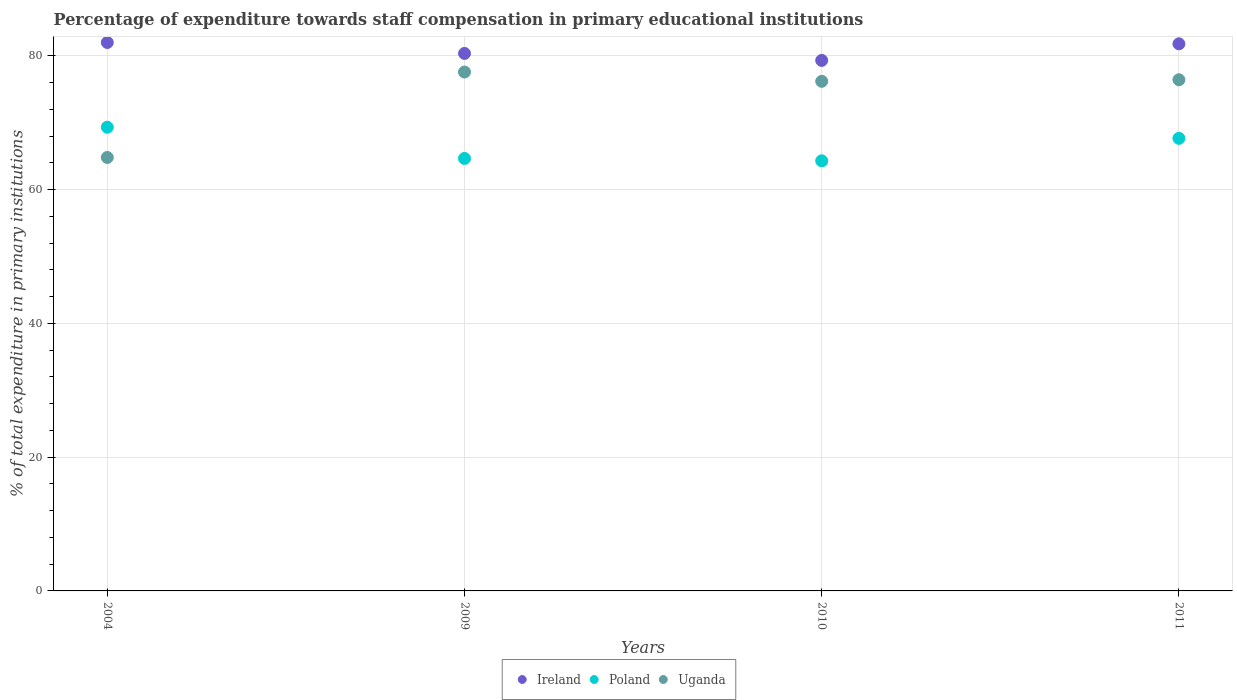How many different coloured dotlines are there?
Your answer should be very brief. 3. What is the percentage of expenditure towards staff compensation in Poland in 2004?
Give a very brief answer. 69.34. Across all years, what is the maximum percentage of expenditure towards staff compensation in Uganda?
Give a very brief answer. 77.58. Across all years, what is the minimum percentage of expenditure towards staff compensation in Ireland?
Keep it short and to the point. 79.32. What is the total percentage of expenditure towards staff compensation in Uganda in the graph?
Offer a terse response. 295.02. What is the difference between the percentage of expenditure towards staff compensation in Poland in 2009 and that in 2011?
Offer a terse response. -3. What is the difference between the percentage of expenditure towards staff compensation in Ireland in 2011 and the percentage of expenditure towards staff compensation in Uganda in 2010?
Your response must be concise. 5.6. What is the average percentage of expenditure towards staff compensation in Uganda per year?
Your answer should be compact. 73.76. In the year 2010, what is the difference between the percentage of expenditure towards staff compensation in Ireland and percentage of expenditure towards staff compensation in Poland?
Ensure brevity in your answer.  15.01. What is the ratio of the percentage of expenditure towards staff compensation in Uganda in 2010 to that in 2011?
Your answer should be compact. 1. What is the difference between the highest and the second highest percentage of expenditure towards staff compensation in Poland?
Offer a very short reply. 1.67. What is the difference between the highest and the lowest percentage of expenditure towards staff compensation in Ireland?
Offer a very short reply. 2.68. Is the sum of the percentage of expenditure towards staff compensation in Uganda in 2009 and 2010 greater than the maximum percentage of expenditure towards staff compensation in Poland across all years?
Offer a very short reply. Yes. Is it the case that in every year, the sum of the percentage of expenditure towards staff compensation in Ireland and percentage of expenditure towards staff compensation in Uganda  is greater than the percentage of expenditure towards staff compensation in Poland?
Give a very brief answer. Yes. Does the percentage of expenditure towards staff compensation in Ireland monotonically increase over the years?
Your answer should be compact. No. Is the percentage of expenditure towards staff compensation in Ireland strictly greater than the percentage of expenditure towards staff compensation in Uganda over the years?
Offer a terse response. Yes. How many dotlines are there?
Keep it short and to the point. 3. How many years are there in the graph?
Offer a very short reply. 4. What is the difference between two consecutive major ticks on the Y-axis?
Ensure brevity in your answer.  20. What is the title of the graph?
Provide a succinct answer. Percentage of expenditure towards staff compensation in primary educational institutions. Does "Slovak Republic" appear as one of the legend labels in the graph?
Keep it short and to the point. No. What is the label or title of the X-axis?
Give a very brief answer. Years. What is the label or title of the Y-axis?
Offer a very short reply. % of total expenditure in primary institutions. What is the % of total expenditure in primary institutions of Ireland in 2004?
Ensure brevity in your answer.  82. What is the % of total expenditure in primary institutions of Poland in 2004?
Ensure brevity in your answer.  69.34. What is the % of total expenditure in primary institutions in Uganda in 2004?
Offer a terse response. 64.81. What is the % of total expenditure in primary institutions of Ireland in 2009?
Your answer should be very brief. 80.37. What is the % of total expenditure in primary institutions in Poland in 2009?
Provide a short and direct response. 64.67. What is the % of total expenditure in primary institutions of Uganda in 2009?
Offer a terse response. 77.58. What is the % of total expenditure in primary institutions in Ireland in 2010?
Your response must be concise. 79.32. What is the % of total expenditure in primary institutions of Poland in 2010?
Provide a succinct answer. 64.31. What is the % of total expenditure in primary institutions of Uganda in 2010?
Provide a succinct answer. 76.2. What is the % of total expenditure in primary institutions in Ireland in 2011?
Provide a short and direct response. 81.8. What is the % of total expenditure in primary institutions in Poland in 2011?
Provide a short and direct response. 67.67. What is the % of total expenditure in primary institutions in Uganda in 2011?
Your answer should be compact. 76.43. Across all years, what is the maximum % of total expenditure in primary institutions of Ireland?
Ensure brevity in your answer.  82. Across all years, what is the maximum % of total expenditure in primary institutions of Poland?
Provide a short and direct response. 69.34. Across all years, what is the maximum % of total expenditure in primary institutions of Uganda?
Your response must be concise. 77.58. Across all years, what is the minimum % of total expenditure in primary institutions in Ireland?
Provide a short and direct response. 79.32. Across all years, what is the minimum % of total expenditure in primary institutions in Poland?
Your response must be concise. 64.31. Across all years, what is the minimum % of total expenditure in primary institutions in Uganda?
Make the answer very short. 64.81. What is the total % of total expenditure in primary institutions in Ireland in the graph?
Your response must be concise. 323.49. What is the total % of total expenditure in primary institutions in Poland in the graph?
Keep it short and to the point. 265.99. What is the total % of total expenditure in primary institutions in Uganda in the graph?
Your answer should be compact. 295.02. What is the difference between the % of total expenditure in primary institutions in Ireland in 2004 and that in 2009?
Offer a very short reply. 1.64. What is the difference between the % of total expenditure in primary institutions of Poland in 2004 and that in 2009?
Your response must be concise. 4.67. What is the difference between the % of total expenditure in primary institutions in Uganda in 2004 and that in 2009?
Your response must be concise. -12.77. What is the difference between the % of total expenditure in primary institutions of Ireland in 2004 and that in 2010?
Your answer should be compact. 2.68. What is the difference between the % of total expenditure in primary institutions of Poland in 2004 and that in 2010?
Ensure brevity in your answer.  5.03. What is the difference between the % of total expenditure in primary institutions of Uganda in 2004 and that in 2010?
Provide a short and direct response. -11.38. What is the difference between the % of total expenditure in primary institutions of Ireland in 2004 and that in 2011?
Give a very brief answer. 0.2. What is the difference between the % of total expenditure in primary institutions of Poland in 2004 and that in 2011?
Give a very brief answer. 1.67. What is the difference between the % of total expenditure in primary institutions of Uganda in 2004 and that in 2011?
Your response must be concise. -11.62. What is the difference between the % of total expenditure in primary institutions in Ireland in 2009 and that in 2010?
Your answer should be compact. 1.04. What is the difference between the % of total expenditure in primary institutions of Poland in 2009 and that in 2010?
Give a very brief answer. 0.36. What is the difference between the % of total expenditure in primary institutions in Uganda in 2009 and that in 2010?
Your response must be concise. 1.39. What is the difference between the % of total expenditure in primary institutions in Ireland in 2009 and that in 2011?
Your answer should be very brief. -1.43. What is the difference between the % of total expenditure in primary institutions in Poland in 2009 and that in 2011?
Ensure brevity in your answer.  -3. What is the difference between the % of total expenditure in primary institutions in Uganda in 2009 and that in 2011?
Your answer should be compact. 1.15. What is the difference between the % of total expenditure in primary institutions in Ireland in 2010 and that in 2011?
Provide a succinct answer. -2.48. What is the difference between the % of total expenditure in primary institutions of Poland in 2010 and that in 2011?
Make the answer very short. -3.36. What is the difference between the % of total expenditure in primary institutions in Uganda in 2010 and that in 2011?
Your answer should be very brief. -0.24. What is the difference between the % of total expenditure in primary institutions in Ireland in 2004 and the % of total expenditure in primary institutions in Poland in 2009?
Offer a terse response. 17.34. What is the difference between the % of total expenditure in primary institutions of Ireland in 2004 and the % of total expenditure in primary institutions of Uganda in 2009?
Provide a succinct answer. 4.42. What is the difference between the % of total expenditure in primary institutions in Poland in 2004 and the % of total expenditure in primary institutions in Uganda in 2009?
Offer a terse response. -8.25. What is the difference between the % of total expenditure in primary institutions in Ireland in 2004 and the % of total expenditure in primary institutions in Poland in 2010?
Provide a succinct answer. 17.69. What is the difference between the % of total expenditure in primary institutions in Ireland in 2004 and the % of total expenditure in primary institutions in Uganda in 2010?
Ensure brevity in your answer.  5.81. What is the difference between the % of total expenditure in primary institutions of Poland in 2004 and the % of total expenditure in primary institutions of Uganda in 2010?
Give a very brief answer. -6.86. What is the difference between the % of total expenditure in primary institutions in Ireland in 2004 and the % of total expenditure in primary institutions in Poland in 2011?
Offer a terse response. 14.33. What is the difference between the % of total expenditure in primary institutions in Ireland in 2004 and the % of total expenditure in primary institutions in Uganda in 2011?
Provide a succinct answer. 5.57. What is the difference between the % of total expenditure in primary institutions of Poland in 2004 and the % of total expenditure in primary institutions of Uganda in 2011?
Keep it short and to the point. -7.1. What is the difference between the % of total expenditure in primary institutions of Ireland in 2009 and the % of total expenditure in primary institutions of Poland in 2010?
Give a very brief answer. 16.05. What is the difference between the % of total expenditure in primary institutions in Ireland in 2009 and the % of total expenditure in primary institutions in Uganda in 2010?
Offer a very short reply. 4.17. What is the difference between the % of total expenditure in primary institutions of Poland in 2009 and the % of total expenditure in primary institutions of Uganda in 2010?
Give a very brief answer. -11.53. What is the difference between the % of total expenditure in primary institutions in Ireland in 2009 and the % of total expenditure in primary institutions in Poland in 2011?
Provide a succinct answer. 12.69. What is the difference between the % of total expenditure in primary institutions of Ireland in 2009 and the % of total expenditure in primary institutions of Uganda in 2011?
Ensure brevity in your answer.  3.93. What is the difference between the % of total expenditure in primary institutions of Poland in 2009 and the % of total expenditure in primary institutions of Uganda in 2011?
Offer a very short reply. -11.77. What is the difference between the % of total expenditure in primary institutions in Ireland in 2010 and the % of total expenditure in primary institutions in Poland in 2011?
Your answer should be compact. 11.65. What is the difference between the % of total expenditure in primary institutions of Ireland in 2010 and the % of total expenditure in primary institutions of Uganda in 2011?
Provide a succinct answer. 2.89. What is the difference between the % of total expenditure in primary institutions in Poland in 2010 and the % of total expenditure in primary institutions in Uganda in 2011?
Your answer should be compact. -12.12. What is the average % of total expenditure in primary institutions of Ireland per year?
Your answer should be very brief. 80.87. What is the average % of total expenditure in primary institutions of Poland per year?
Make the answer very short. 66.5. What is the average % of total expenditure in primary institutions of Uganda per year?
Your answer should be very brief. 73.76. In the year 2004, what is the difference between the % of total expenditure in primary institutions of Ireland and % of total expenditure in primary institutions of Poland?
Offer a terse response. 12.67. In the year 2004, what is the difference between the % of total expenditure in primary institutions of Ireland and % of total expenditure in primary institutions of Uganda?
Give a very brief answer. 17.19. In the year 2004, what is the difference between the % of total expenditure in primary institutions in Poland and % of total expenditure in primary institutions in Uganda?
Offer a very short reply. 4.52. In the year 2009, what is the difference between the % of total expenditure in primary institutions of Ireland and % of total expenditure in primary institutions of Poland?
Offer a terse response. 15.7. In the year 2009, what is the difference between the % of total expenditure in primary institutions in Ireland and % of total expenditure in primary institutions in Uganda?
Ensure brevity in your answer.  2.78. In the year 2009, what is the difference between the % of total expenditure in primary institutions of Poland and % of total expenditure in primary institutions of Uganda?
Provide a succinct answer. -12.92. In the year 2010, what is the difference between the % of total expenditure in primary institutions in Ireland and % of total expenditure in primary institutions in Poland?
Your response must be concise. 15.01. In the year 2010, what is the difference between the % of total expenditure in primary institutions of Ireland and % of total expenditure in primary institutions of Uganda?
Ensure brevity in your answer.  3.13. In the year 2010, what is the difference between the % of total expenditure in primary institutions of Poland and % of total expenditure in primary institutions of Uganda?
Your answer should be compact. -11.88. In the year 2011, what is the difference between the % of total expenditure in primary institutions of Ireland and % of total expenditure in primary institutions of Poland?
Give a very brief answer. 14.13. In the year 2011, what is the difference between the % of total expenditure in primary institutions in Ireland and % of total expenditure in primary institutions in Uganda?
Make the answer very short. 5.37. In the year 2011, what is the difference between the % of total expenditure in primary institutions in Poland and % of total expenditure in primary institutions in Uganda?
Offer a terse response. -8.76. What is the ratio of the % of total expenditure in primary institutions in Ireland in 2004 to that in 2009?
Offer a terse response. 1.02. What is the ratio of the % of total expenditure in primary institutions in Poland in 2004 to that in 2009?
Your answer should be very brief. 1.07. What is the ratio of the % of total expenditure in primary institutions in Uganda in 2004 to that in 2009?
Keep it short and to the point. 0.84. What is the ratio of the % of total expenditure in primary institutions in Ireland in 2004 to that in 2010?
Ensure brevity in your answer.  1.03. What is the ratio of the % of total expenditure in primary institutions of Poland in 2004 to that in 2010?
Provide a succinct answer. 1.08. What is the ratio of the % of total expenditure in primary institutions of Uganda in 2004 to that in 2010?
Provide a short and direct response. 0.85. What is the ratio of the % of total expenditure in primary institutions in Poland in 2004 to that in 2011?
Offer a terse response. 1.02. What is the ratio of the % of total expenditure in primary institutions in Uganda in 2004 to that in 2011?
Give a very brief answer. 0.85. What is the ratio of the % of total expenditure in primary institutions in Ireland in 2009 to that in 2010?
Provide a short and direct response. 1.01. What is the ratio of the % of total expenditure in primary institutions of Uganda in 2009 to that in 2010?
Ensure brevity in your answer.  1.02. What is the ratio of the % of total expenditure in primary institutions of Ireland in 2009 to that in 2011?
Make the answer very short. 0.98. What is the ratio of the % of total expenditure in primary institutions in Poland in 2009 to that in 2011?
Your response must be concise. 0.96. What is the ratio of the % of total expenditure in primary institutions of Uganda in 2009 to that in 2011?
Offer a very short reply. 1.02. What is the ratio of the % of total expenditure in primary institutions in Ireland in 2010 to that in 2011?
Your answer should be very brief. 0.97. What is the ratio of the % of total expenditure in primary institutions of Poland in 2010 to that in 2011?
Keep it short and to the point. 0.95. What is the difference between the highest and the second highest % of total expenditure in primary institutions in Ireland?
Your answer should be compact. 0.2. What is the difference between the highest and the second highest % of total expenditure in primary institutions of Poland?
Your answer should be compact. 1.67. What is the difference between the highest and the second highest % of total expenditure in primary institutions of Uganda?
Your response must be concise. 1.15. What is the difference between the highest and the lowest % of total expenditure in primary institutions in Ireland?
Give a very brief answer. 2.68. What is the difference between the highest and the lowest % of total expenditure in primary institutions of Poland?
Keep it short and to the point. 5.03. What is the difference between the highest and the lowest % of total expenditure in primary institutions in Uganda?
Give a very brief answer. 12.77. 